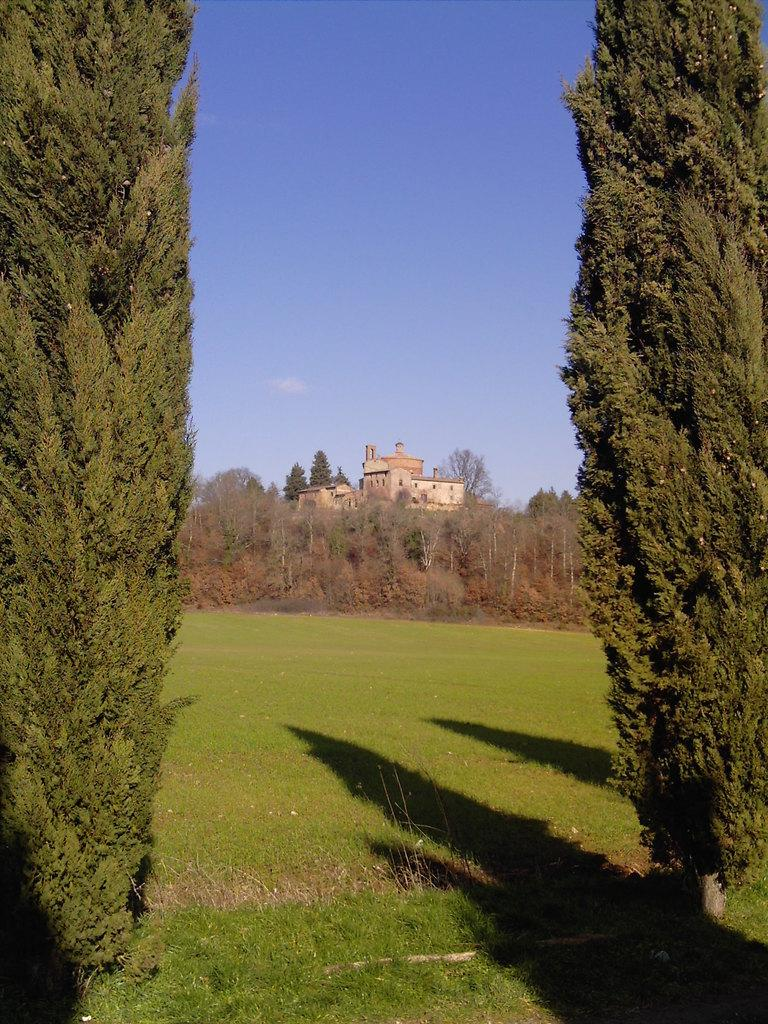What type of vegetation can be seen in the front of the image? There are trees in the front of the image on a grassland. What structure is visible in the image? There is a building visible in the image. How are the trees positioned in relation to the building? Trees are present around the building. What part of the natural environment is visible above the building? The sky is visible above the building. What type of ring can be seen on the leaf in the image? There is no leaf or ring present in the image. Can you tell me what the dad is doing in the image? There is no dad present in the image. 